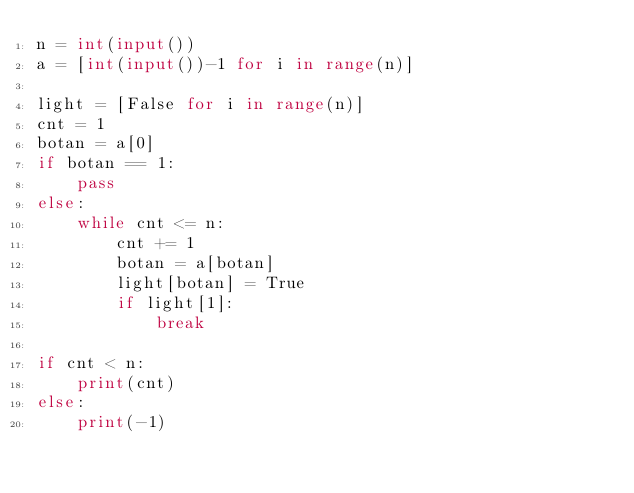Convert code to text. <code><loc_0><loc_0><loc_500><loc_500><_Python_>n = int(input())
a = [int(input())-1 for i in range(n)]
 
light = [False for i in range(n)]
cnt = 1
botan = a[0]
if botan == 1:
    pass
else:
    while cnt <= n:
        cnt += 1
        botan = a[botan]
        light[botan] = True
        if light[1]:
            break
 
if cnt < n:
    print(cnt)
else:
    print(-1)</code> 